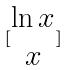Convert formula to latex. <formula><loc_0><loc_0><loc_500><loc_500>[ \begin{matrix} \ln x \\ x \end{matrix} ]</formula> 